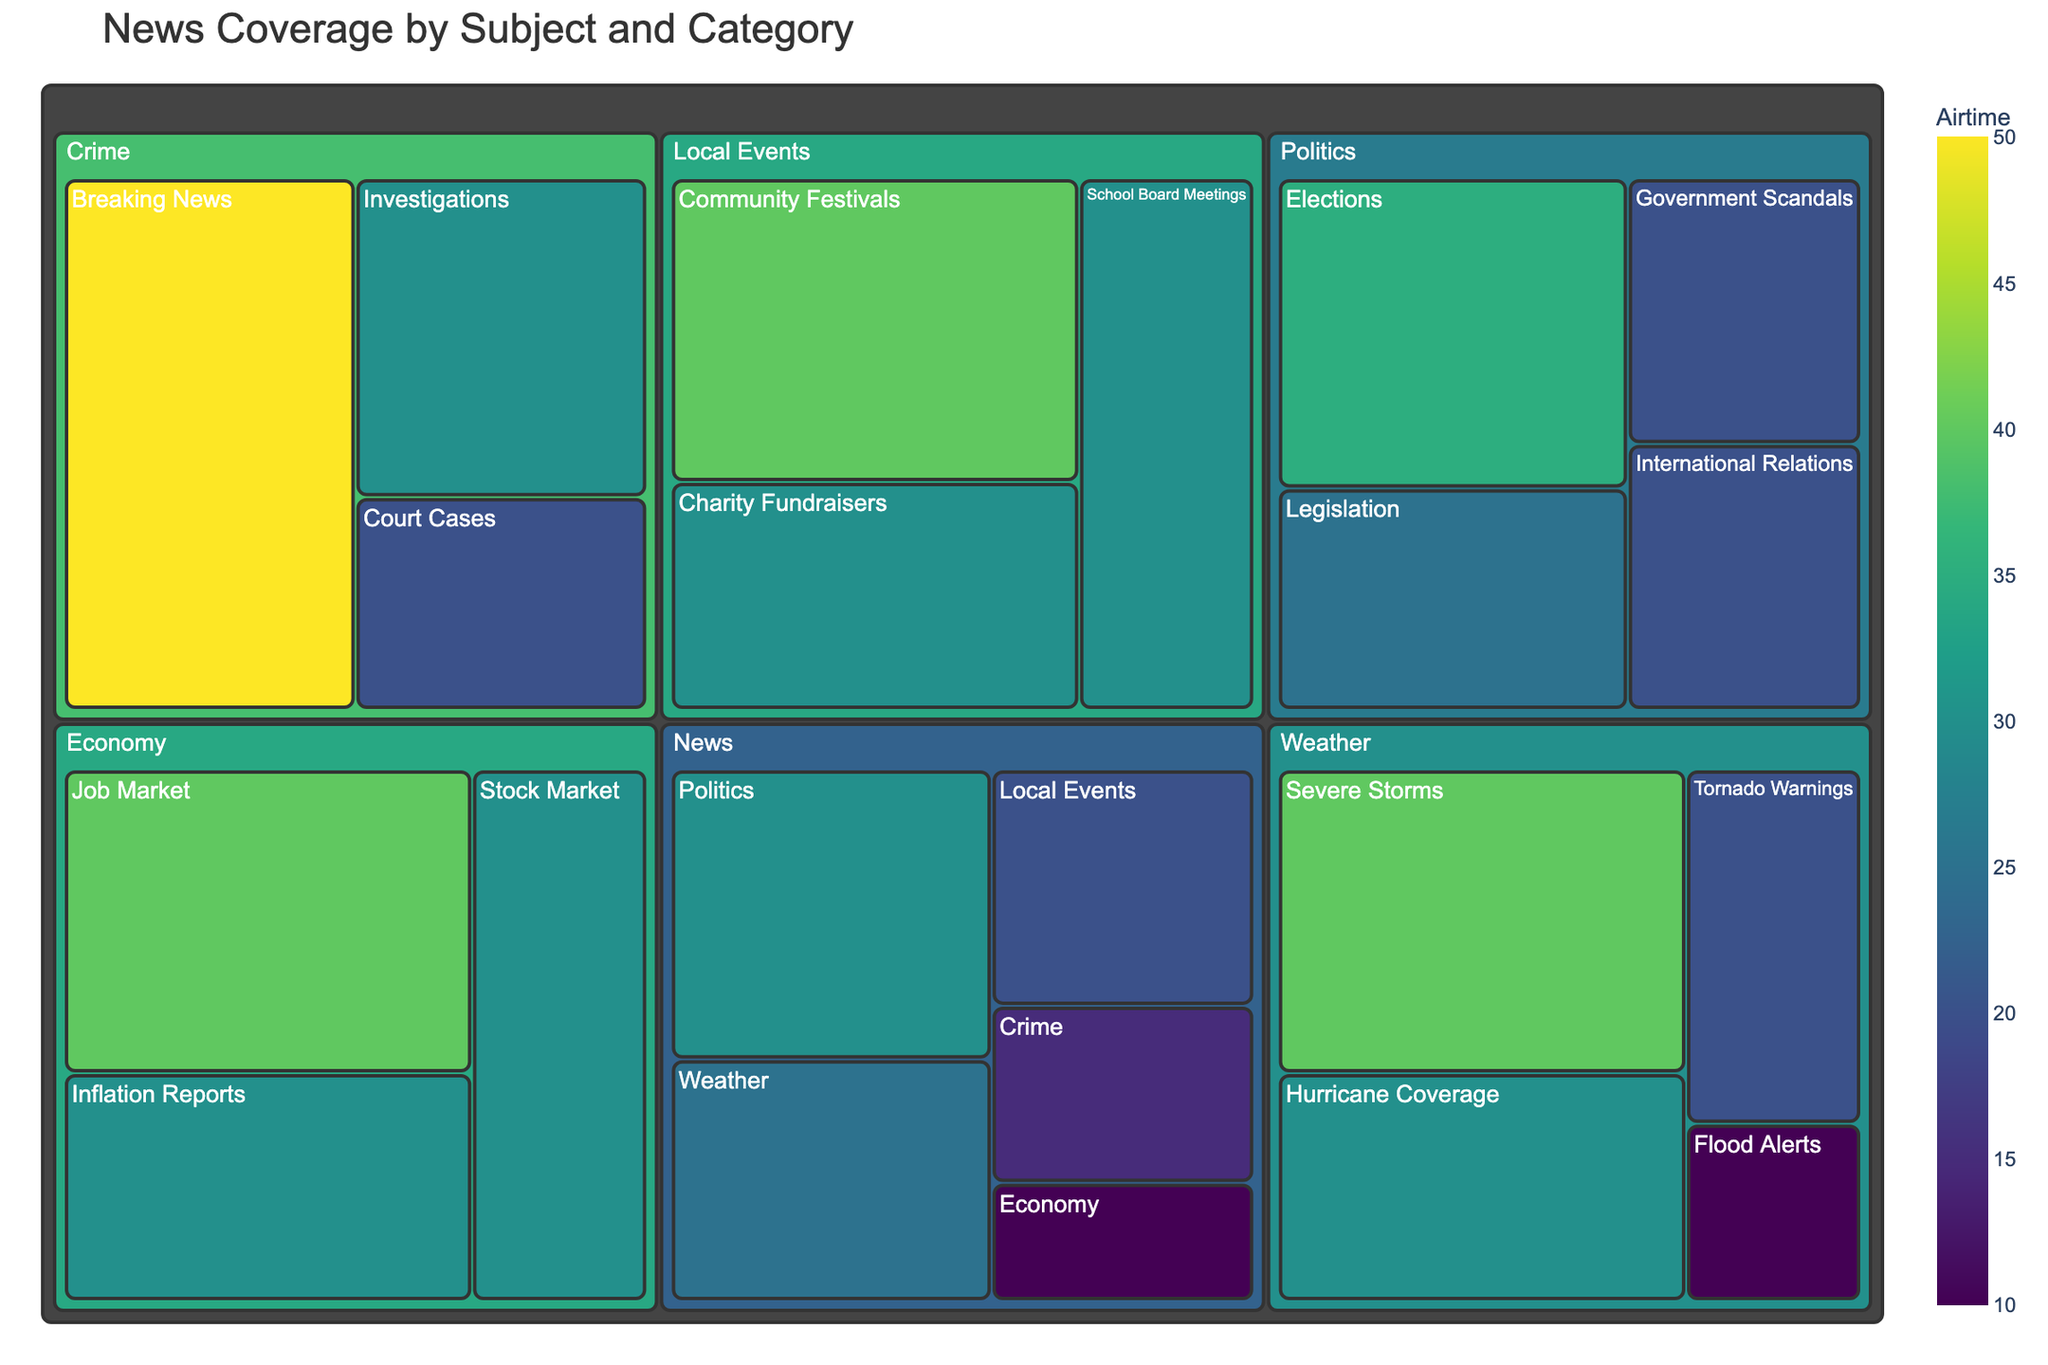How much airtime is allocated to "Breaking News" in the Crime subject? To find the airtime for "Breaking News" in the Crime subject, locate the category "Breaking News" under the subject "Crime". The treemap will show the airtime allocation for each category.
Answer: 50 Which category under Weather has the highest airtime allocation? Look under the Weather section of the treemap and identify the category with the largest allocated airtime.
Answer: Severe Storms What is the combined airtime for all categories under the Politics subject? Sum the airtime for all categories under Politics: Elections (35), Legislation (25), International Relations (20), Government Scandals (20). The combined airtime is 35 + 25 + 20 + 20 = 100.
Answer: 100 Compare the airtime allocated to "Job Market" in Economy with "Community Festivals" in Local Events. Which category has more airtime? Check the treemap for the airtime allocations: Job Market in Economy (40) and Community Festivals in Local Events (40). Since both have the same airtime, no category has more airtime.
Answer: Both are equal How many subjects have categories with an airtime allocation of 30 or more? Identify the subjects with at least one category having 30 or more airtime: News (Politics, Weather), Weather (Severe Storms, Hurricane Coverage, Tornado Warnings), Politics (Elections, Legislation), Local Events (Community Festivals, School Board Meetings, Charity Fundraisers), Crime (Breaking News, Investigations), Economy (Job Market, Stock Market, Inflation Reports). Count the unique subjects.
Answer: 5 (News, Weather, Politics, Local Events, Crime, Economy) What is the largest single airtime allocation within the Weather subject? Locate the largest airtime allocation within the Weather subject on the treemap. The category with the highest value is Severe Storms with 40.
Answer: 40 Is the airtime for "Legislation" in Politics higher than "Hurricane Coverage" in Weather? Compare the airtime values: Legislation in Politics (25) and Hurricane Coverage in Weather (30). Hurricane Coverage has more airtime.
Answer: No What is the total airtime allocated to all categories under News? Sum the airtime for all categories under News: Politics (30), Weather (25), Local Events (20), Crime (15), Economy (10). The total airtime is 30 + 25 + 20 + 15 + 10 = 100.
Answer: 100 How does the airtime for "Court Cases" in Crime compare to "Charity Fundraisers" in Local Events? Compare the airtime values: Court Cases in Crime (20) and Charity Fundraisers in Local Events (30). Charity Fundraisers has more airtime.
Answer: Charity Fundraisers has more Which category under the subject of Economy has been allocated the most airtime? Check the categories under Economy in the treemap: Job Market (40), Stock Market (30), Inflation Reports (30). The Job Market category has the most airtime.
Answer: Job Market 